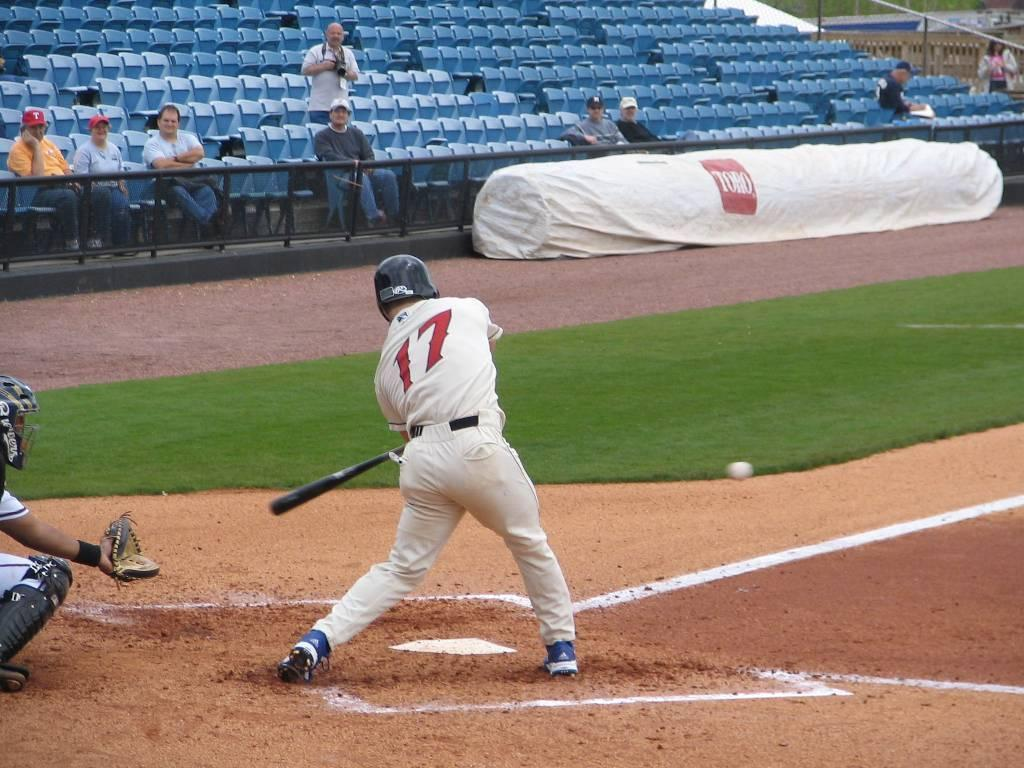Provide a one-sentence caption for the provided image. A person readies to hit a ball as they wear 17. 